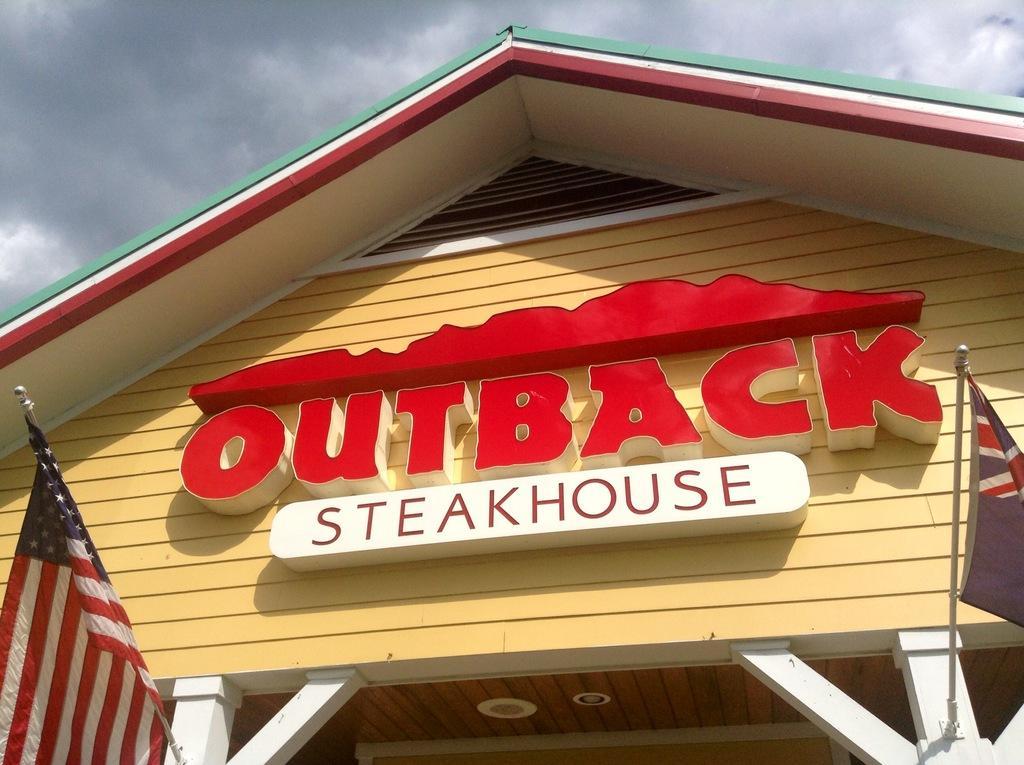Could you give a brief overview of what you see in this image? In this picture we can see a name board on the wall, flags, some objects and in the background we can see the sky. 